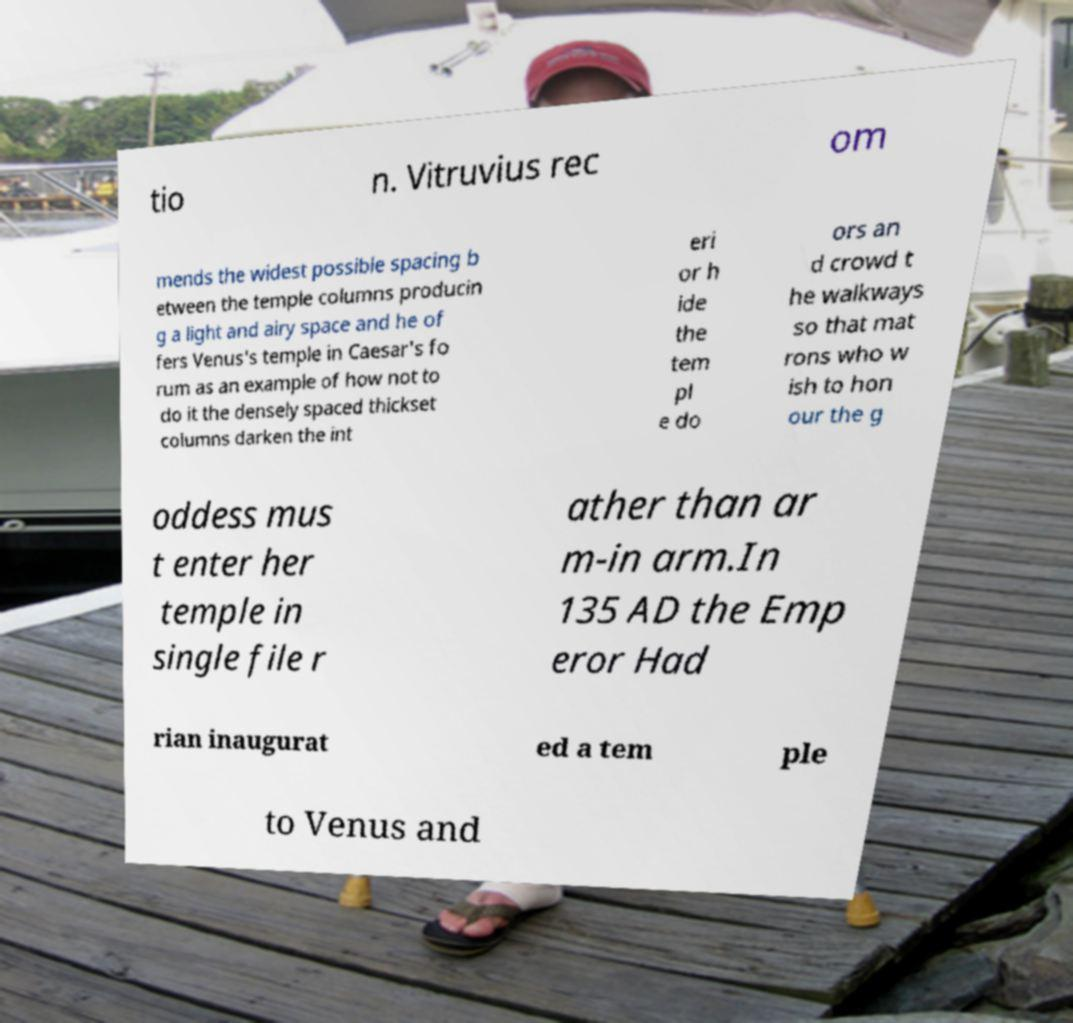I need the written content from this picture converted into text. Can you do that? tio n. Vitruvius rec om mends the widest possible spacing b etween the temple columns producin g a light and airy space and he of fers Venus's temple in Caesar's fo rum as an example of how not to do it the densely spaced thickset columns darken the int eri or h ide the tem pl e do ors an d crowd t he walkways so that mat rons who w ish to hon our the g oddess mus t enter her temple in single file r ather than ar m-in arm.In 135 AD the Emp eror Had rian inaugurat ed a tem ple to Venus and 